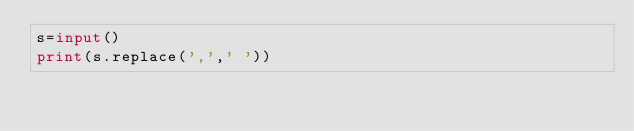<code> <loc_0><loc_0><loc_500><loc_500><_Python_>s=input()
print(s.replace(',',' '))
</code> 